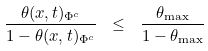<formula> <loc_0><loc_0><loc_500><loc_500>\frac { \theta ( x , t ) _ { \Phi ^ { c } } } { 1 - \theta ( x , t ) _ { \Phi ^ { c } } } \ \leq \ \frac { \theta _ { \max } } { 1 - \theta _ { \max } }</formula> 